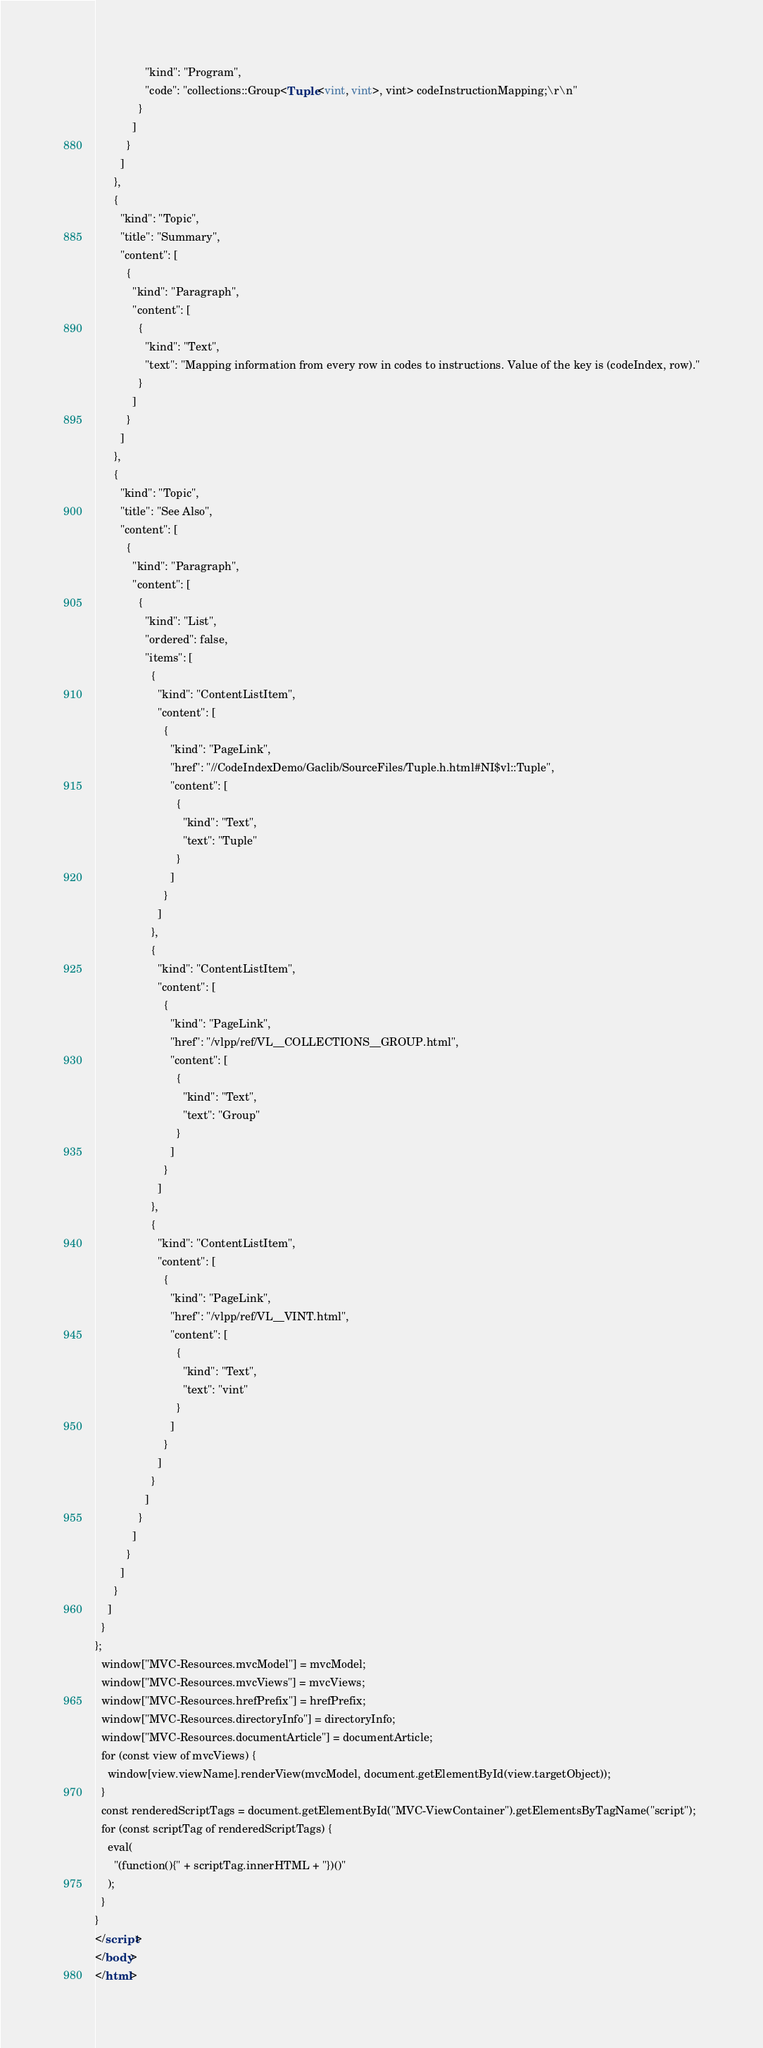Convert code to text. <code><loc_0><loc_0><loc_500><loc_500><_HTML_>                "kind": "Program",
                "code": "collections::Group<Tuple<vint, vint>, vint> codeInstructionMapping;\r\n"
              }
            ]
          }
        ]
      },
      {
        "kind": "Topic",
        "title": "Summary",
        "content": [
          {
            "kind": "Paragraph",
            "content": [
              {
                "kind": "Text",
                "text": "Mapping information from every row in codes to instructions. Value of the key is (codeIndex, row)."
              }
            ]
          }
        ]
      },
      {
        "kind": "Topic",
        "title": "See Also",
        "content": [
          {
            "kind": "Paragraph",
            "content": [
              {
                "kind": "List",
                "ordered": false,
                "items": [
                  {
                    "kind": "ContentListItem",
                    "content": [
                      {
                        "kind": "PageLink",
                        "href": "//CodeIndexDemo/Gaclib/SourceFiles/Tuple.h.html#NI$vl::Tuple",
                        "content": [
                          {
                            "kind": "Text",
                            "text": "Tuple"
                          }
                        ]
                      }
                    ]
                  },
                  {
                    "kind": "ContentListItem",
                    "content": [
                      {
                        "kind": "PageLink",
                        "href": "/vlpp/ref/VL__COLLECTIONS__GROUP.html",
                        "content": [
                          {
                            "kind": "Text",
                            "text": "Group"
                          }
                        ]
                      }
                    ]
                  },
                  {
                    "kind": "ContentListItem",
                    "content": [
                      {
                        "kind": "PageLink",
                        "href": "/vlpp/ref/VL__VINT.html",
                        "content": [
                          {
                            "kind": "Text",
                            "text": "vint"
                          }
                        ]
                      }
                    ]
                  }
                ]
              }
            ]
          }
        ]
      }
    ]
  }
};
  window["MVC-Resources.mvcModel"] = mvcModel;
  window["MVC-Resources.mvcViews"] = mvcViews;
  window["MVC-Resources.hrefPrefix"] = hrefPrefix;
  window["MVC-Resources.directoryInfo"] = directoryInfo;
  window["MVC-Resources.documentArticle"] = documentArticle;
  for (const view of mvcViews) {
    window[view.viewName].renderView(mvcModel, document.getElementById(view.targetObject));
  }
  const renderedScriptTags = document.getElementById("MVC-ViewContainer").getElementsByTagName("script");
  for (const scriptTag of renderedScriptTags) {
    eval(
      "(function(){" + scriptTag.innerHTML + "})()"
    );
  }
}
</script>
</body>
</html>
</code> 